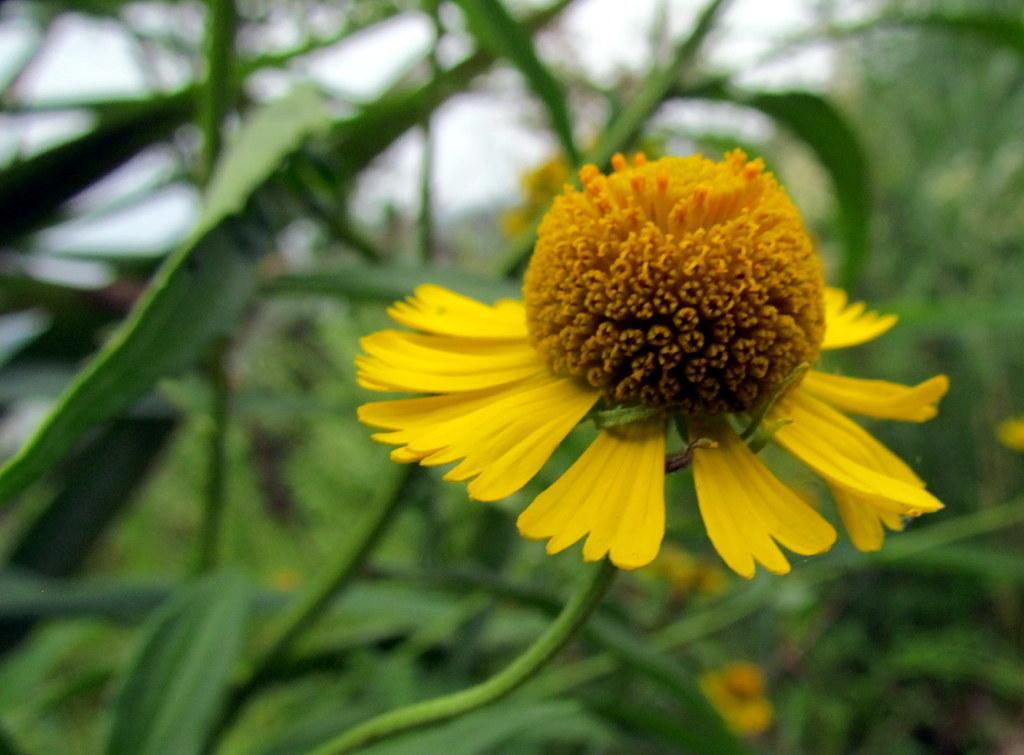What is the main subject in the foreground of the image? There is a flower in the foreground of the image. What can be seen in the background of the image? There are leaves in the background of the image. What type of nail is being used by the committee in the image? There is no nail or committee present in the image; it features a flower and leaves. How does the comb affect the appearance of the flower in the image? There is no comb present in the image; it features a flower and leaves. 